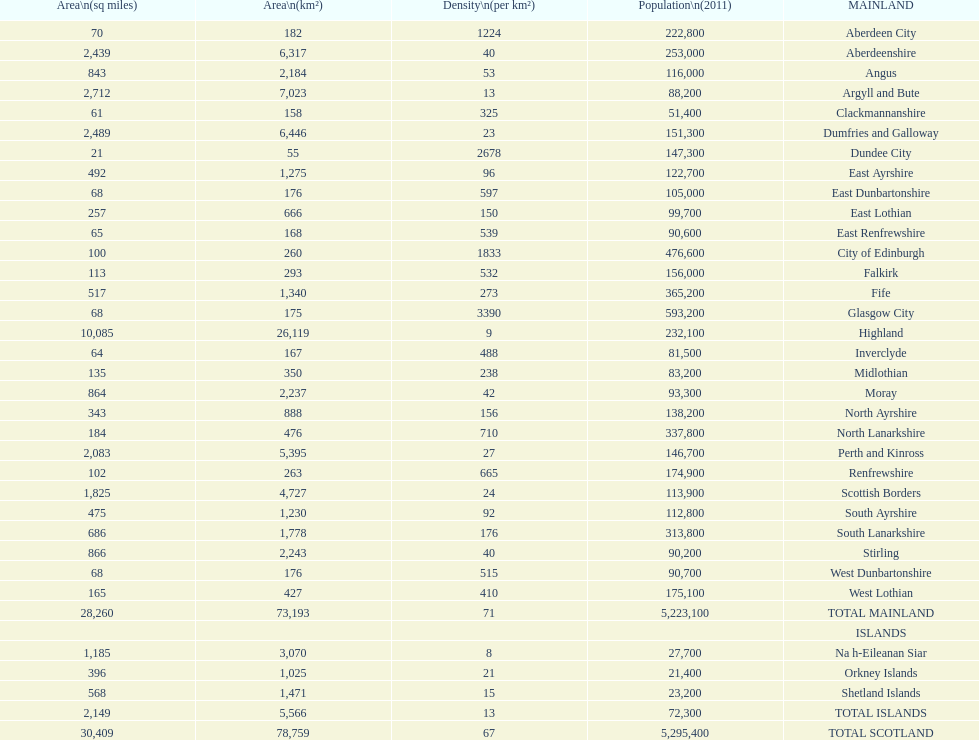Which is the only subdivision to have a greater area than argyll and bute? Highland. 